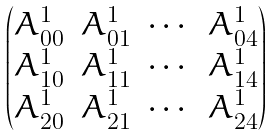Convert formula to latex. <formula><loc_0><loc_0><loc_500><loc_500>\begin{pmatrix} A _ { 0 0 } ^ { 1 } & A _ { 0 1 } ^ { 1 } & \cdots & A _ { 0 4 } ^ { 1 } \\ A _ { 1 0 } ^ { 1 } & A _ { 1 1 } ^ { 1 } & \cdots & A _ { 1 4 } ^ { 1 } \\ A _ { 2 0 } ^ { 1 } & A _ { 2 1 } ^ { 1 } & \cdots & A _ { 2 4 } ^ { 1 } \end{pmatrix}</formula> 